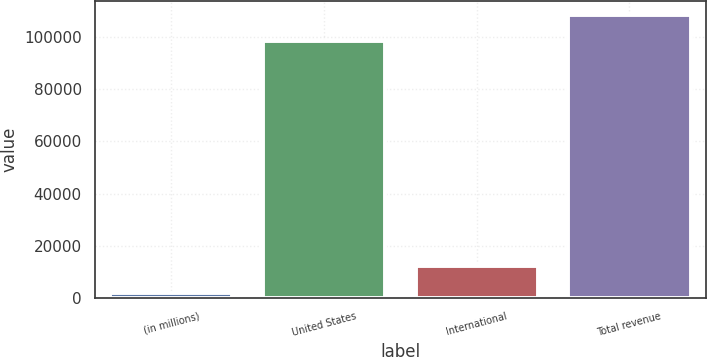Convert chart to OTSL. <chart><loc_0><loc_0><loc_500><loc_500><bar_chart><fcel>(in millions)<fcel>United States<fcel>International<fcel>Total revenue<nl><fcel>2015<fcel>98435<fcel>12066.6<fcel>108487<nl></chart> 